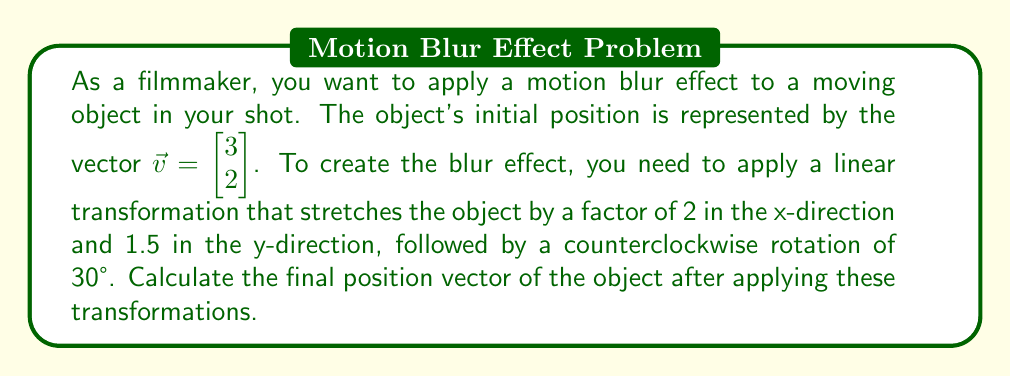Can you solve this math problem? Let's approach this step-by-step:

1) First, we need to create the scaling matrix:
   $$S = \begin{bmatrix} 2 & 0 \\ 0 & 1.5 \end{bmatrix}$$

2) Next, we need the rotation matrix for 30° counterclockwise:
   $$R = \begin{bmatrix} \cos 30° & -\sin 30° \\ \sin 30° & \cos 30° \end{bmatrix} = \begin{bmatrix} \frac{\sqrt{3}}{2} & -\frac{1}{2} \\ \frac{1}{2} & \frac{\sqrt{3}}{2} \end{bmatrix}$$

3) The combined transformation matrix is the product of R and S:
   $$T = RS = \begin{bmatrix} \frac{\sqrt{3}}{2} & -\frac{1}{2} \\ \frac{1}{2} & \frac{\sqrt{3}}{2} \end{bmatrix} \begin{bmatrix} 2 & 0 \\ 0 & 1.5 \end{bmatrix} = \begin{bmatrix} \sqrt{3} & -\frac{3}{4} \\ 1 & \frac{3\sqrt{3}}{4} \end{bmatrix}$$

4) Now, we apply this transformation to our initial vector:
   $$\vec{v}_{final} = T\vec{v} = \begin{bmatrix} \sqrt{3} & -\frac{3}{4} \\ 1 & \frac{3\sqrt{3}}{4} \end{bmatrix} \begin{bmatrix} 3 \\ 2 \end{bmatrix}$$

5) Calculating this:
   $$\vec{v}_{final} = \begin{bmatrix} 3\sqrt{3} - \frac{3}{2} \\ 3 + \frac{3\sqrt{3}}{2} \end{bmatrix} = \begin{bmatrix} 3\sqrt{3} - 1.5 \\ 3 + 1.5\sqrt{3} \end{bmatrix}$$
Answer: $\vec{v}_{final} = \begin{bmatrix} 3\sqrt{3} - 1.5 \\ 3 + 1.5\sqrt{3} \end{bmatrix}$ 